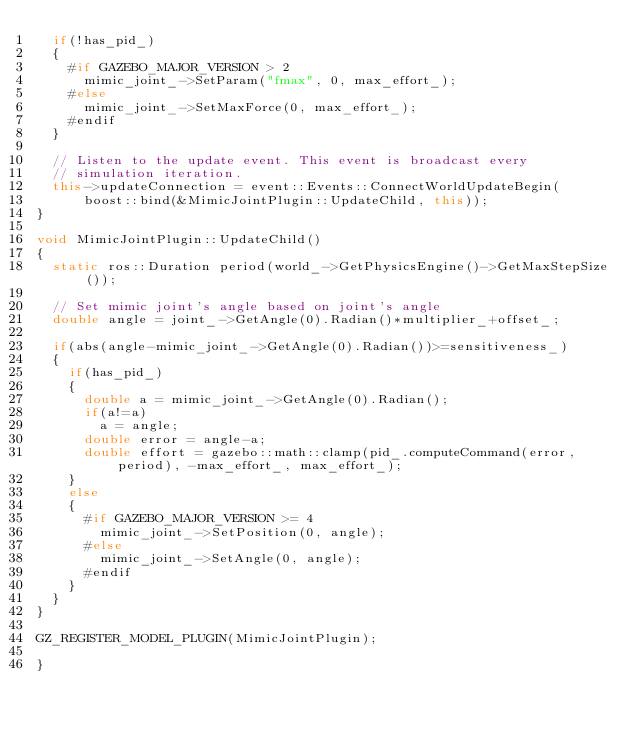Convert code to text. <code><loc_0><loc_0><loc_500><loc_500><_C++_>  if(!has_pid_)
  {
    #if GAZEBO_MAJOR_VERSION > 2
      mimic_joint_->SetParam("fmax", 0, max_effort_);
    #else
      mimic_joint_->SetMaxForce(0, max_effort_);
    #endif
  }

  // Listen to the update event. This event is broadcast every
  // simulation iteration.
  this->updateConnection = event::Events::ConnectWorldUpdateBegin(
      boost::bind(&MimicJointPlugin::UpdateChild, this));
}

void MimicJointPlugin::UpdateChild()
{
  static ros::Duration period(world_->GetPhysicsEngine()->GetMaxStepSize());

  // Set mimic joint's angle based on joint's angle
  double angle = joint_->GetAngle(0).Radian()*multiplier_+offset_;
  
  if(abs(angle-mimic_joint_->GetAngle(0).Radian())>=sensitiveness_)
  {
    if(has_pid_)
    {
      double a = mimic_joint_->GetAngle(0).Radian();
      if(a!=a)
        a = angle;
      double error = angle-a;
      double effort = gazebo::math::clamp(pid_.computeCommand(error, period), -max_effort_, max_effort_);
    }
    else
    {
      #if GAZEBO_MAJOR_VERSION >= 4
        mimic_joint_->SetPosition(0, angle);
      #else
        mimic_joint_->SetAngle(0, angle);
      #endif
    }
  }
}

GZ_REGISTER_MODEL_PLUGIN(MimicJointPlugin);

}
</code> 